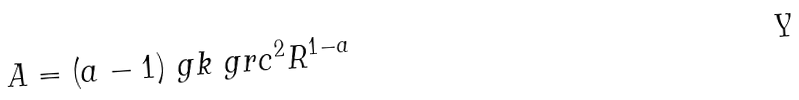<formula> <loc_0><loc_0><loc_500><loc_500>A = ( a - 1 ) \ g k \ g r c ^ { 2 } R ^ { 1 - a }</formula> 